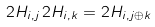Convert formula to latex. <formula><loc_0><loc_0><loc_500><loc_500>2 H _ { i , j } \, 2 H _ { i , k } = 2 H _ { i , j \oplus k }</formula> 